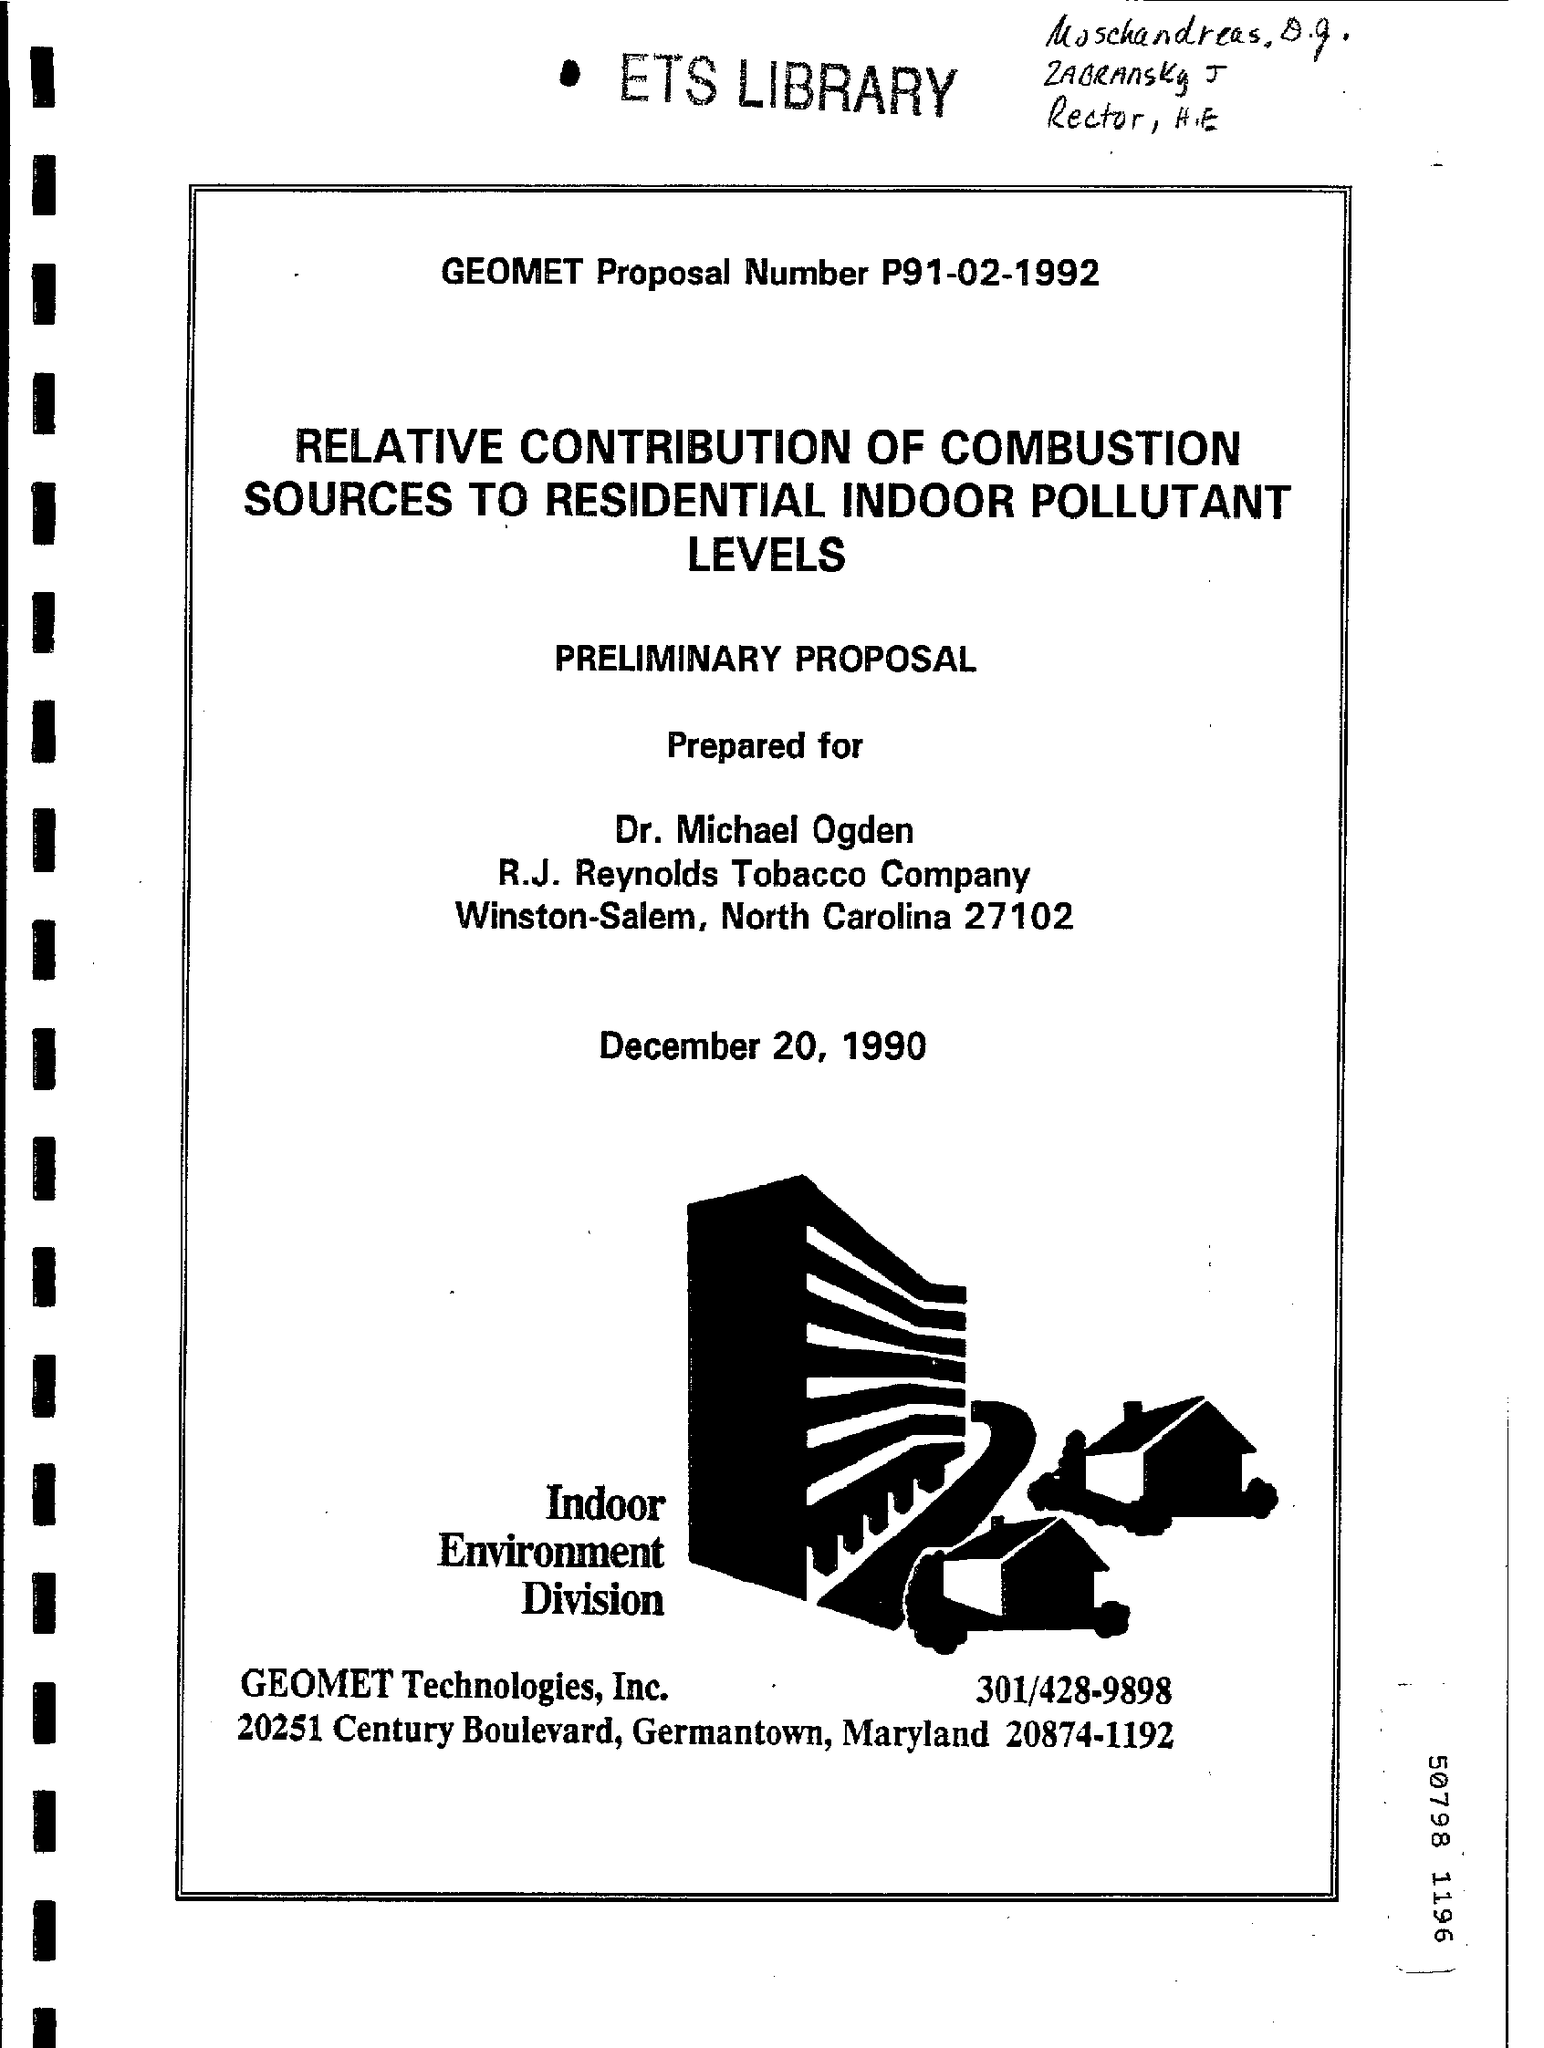What is the GEOMET Proposal Number?
Your answer should be compact. P91-02-1992. 